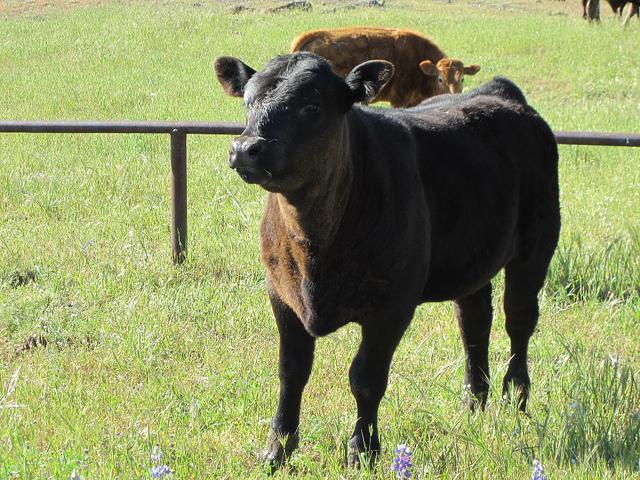How many cows are there?
Give a very brief answer. 2. How many people are wearing a blue shirt?
Give a very brief answer. 0. 